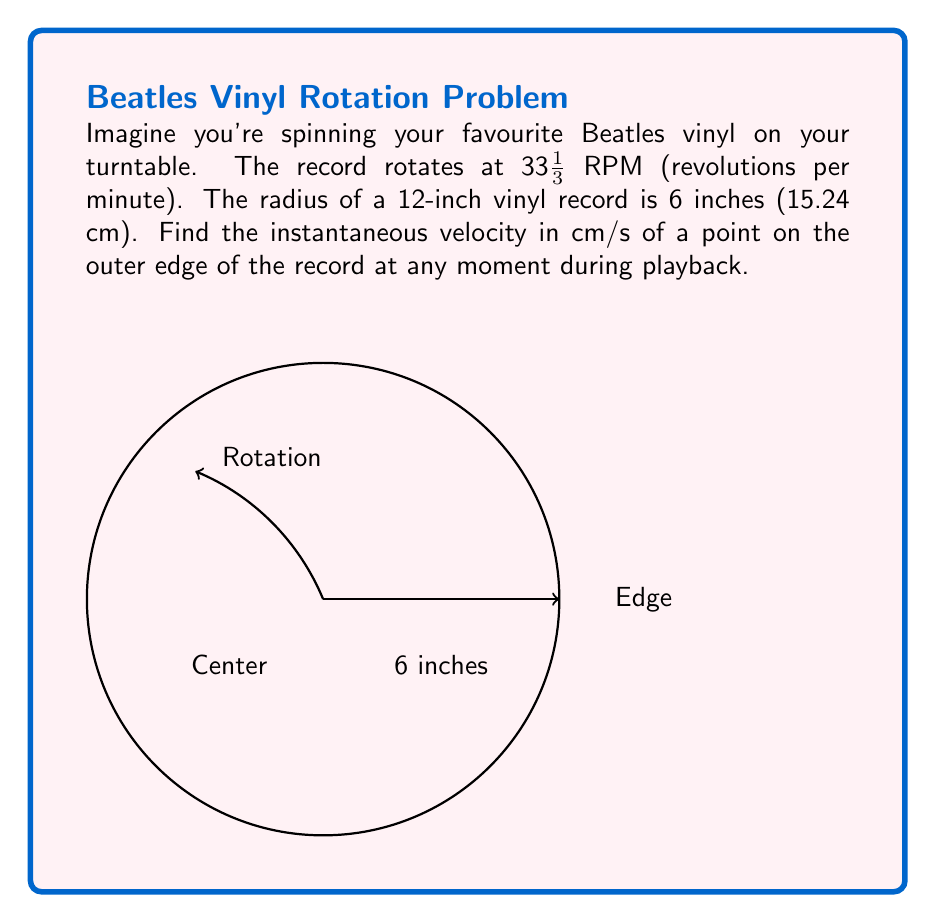Solve this math problem. Let's approach this groovy problem step by step:

1) First, we need to convert the angular velocity from RPM to radians per second:
   $$ \omega = 33\frac{1}{3} \cdot \frac{2\pi}{60} \approx 3.49 \text{ rad/s} $$

2) Now, we know that for circular motion, the instantaneous velocity $v$ at any point on the edge is given by:
   $$ v = r\omega $$
   where $r$ is the radius and $\omega$ is the angular velocity in radians per second.

3) We're given the radius in inches, so let's convert it to centimeters:
   $$ r = 6 \text{ inches} = 15.24 \text{ cm} $$

4) Now we can plug these values into our equation:
   $$ v = r\omega = 15.24 \cdot 3.49 \approx 53.19 \text{ cm/s} $$

5) This velocity is constant for any point on the edge of the record at any time during playback, as long as the turntable maintains a constant speed.
Answer: $v \approx 53.19 \text{ cm/s}$ 